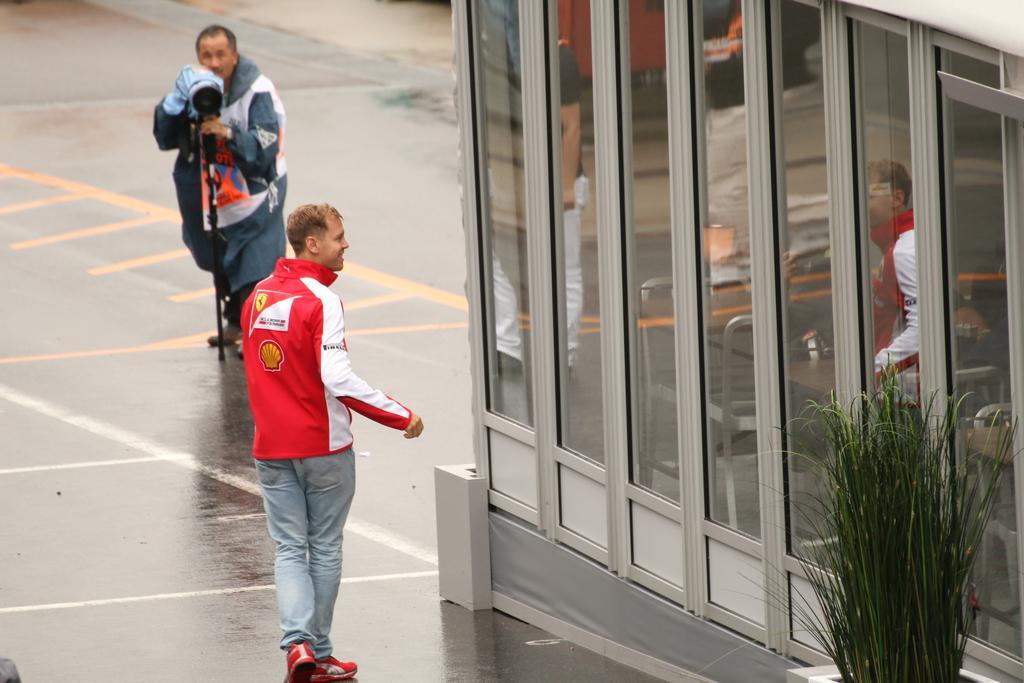How would you summarize this image in a sentence or two? The picture is taken on the streets of a city. In the foreground of the picture there are building, plant and a person walking. In the background there is a person holding a camera. The road is wet. 